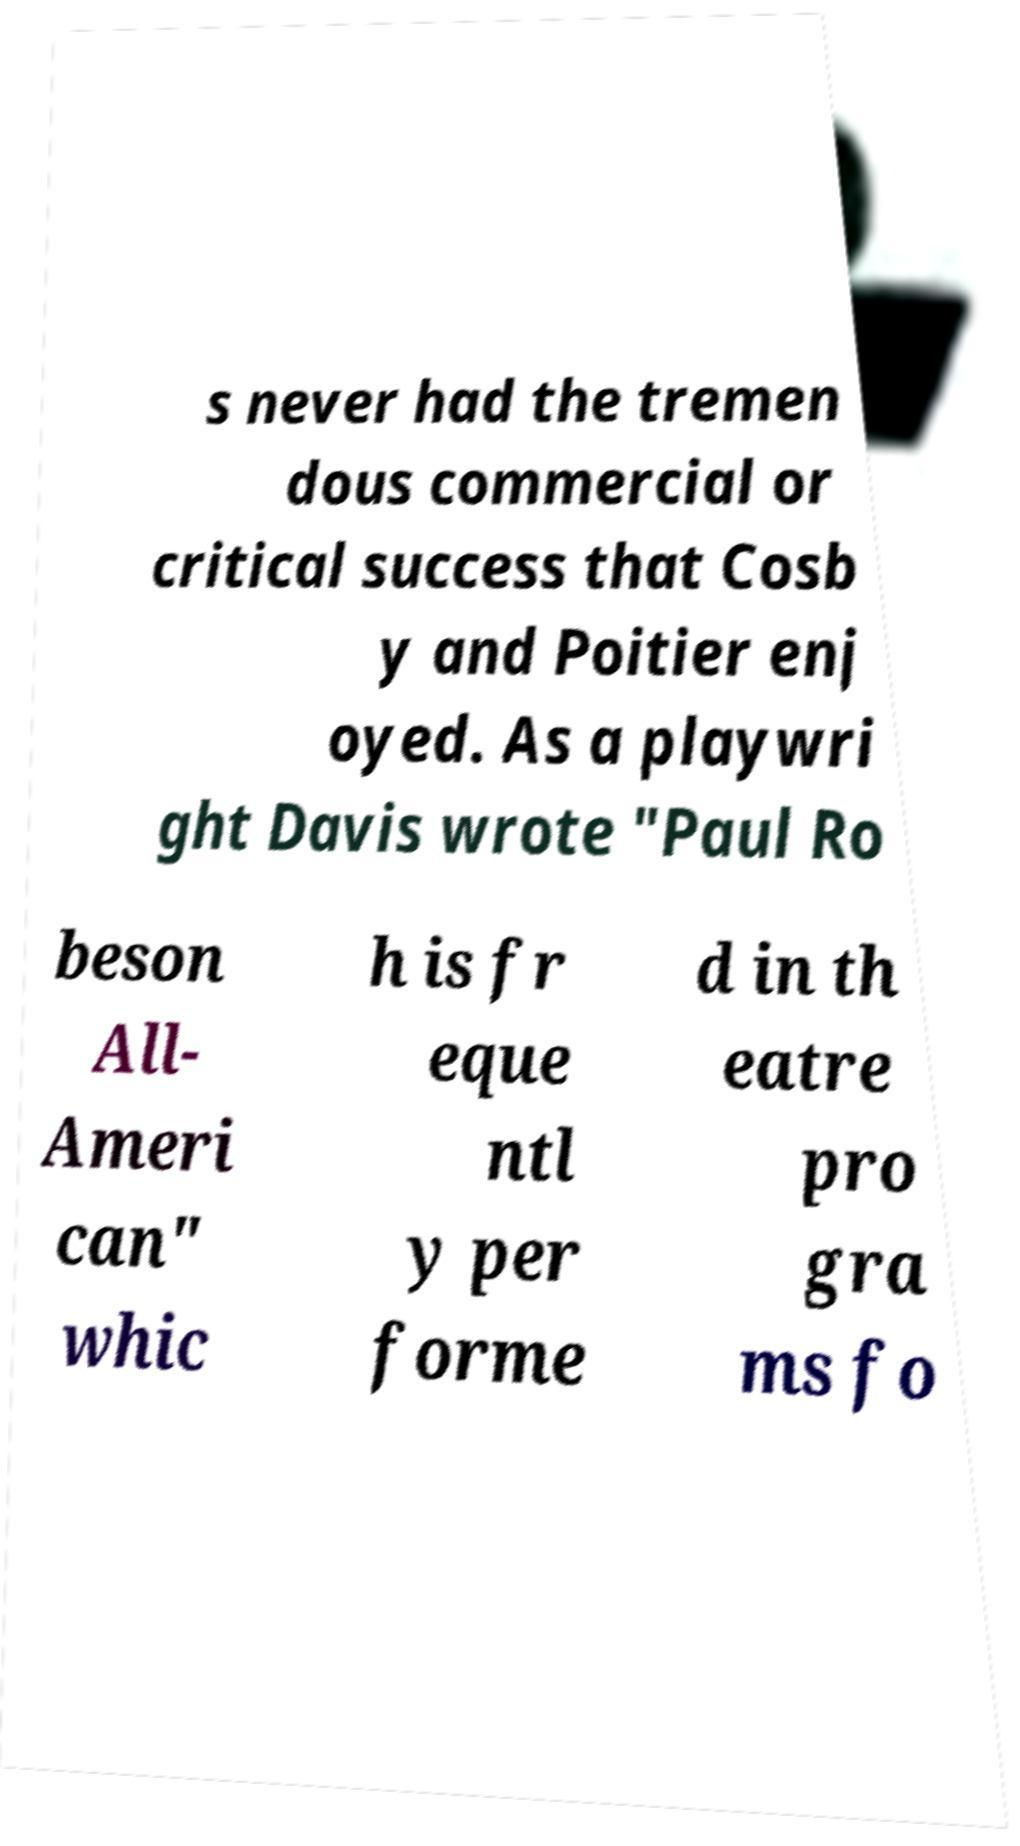Could you assist in decoding the text presented in this image and type it out clearly? s never had the tremen dous commercial or critical success that Cosb y and Poitier enj oyed. As a playwri ght Davis wrote "Paul Ro beson All- Ameri can" whic h is fr eque ntl y per forme d in th eatre pro gra ms fo 